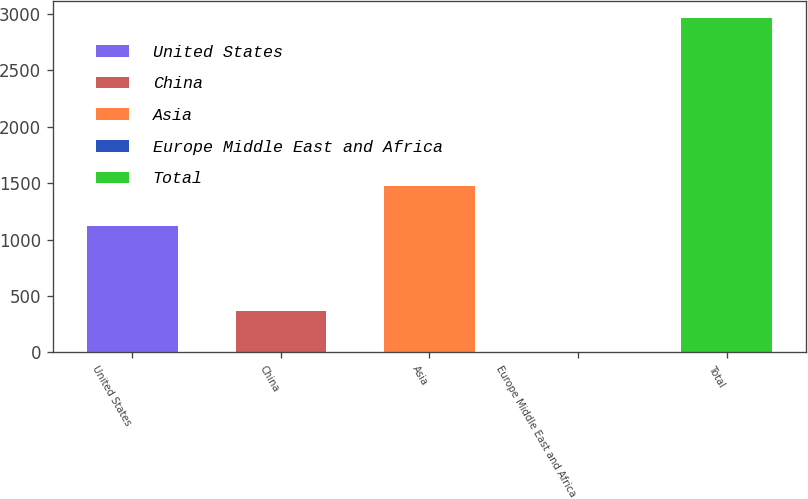Convert chart to OTSL. <chart><loc_0><loc_0><loc_500><loc_500><bar_chart><fcel>United States<fcel>China<fcel>Asia<fcel>Europe Middle East and Africa<fcel>Total<nl><fcel>1121<fcel>367<fcel>1473<fcel>4<fcel>2965<nl></chart> 